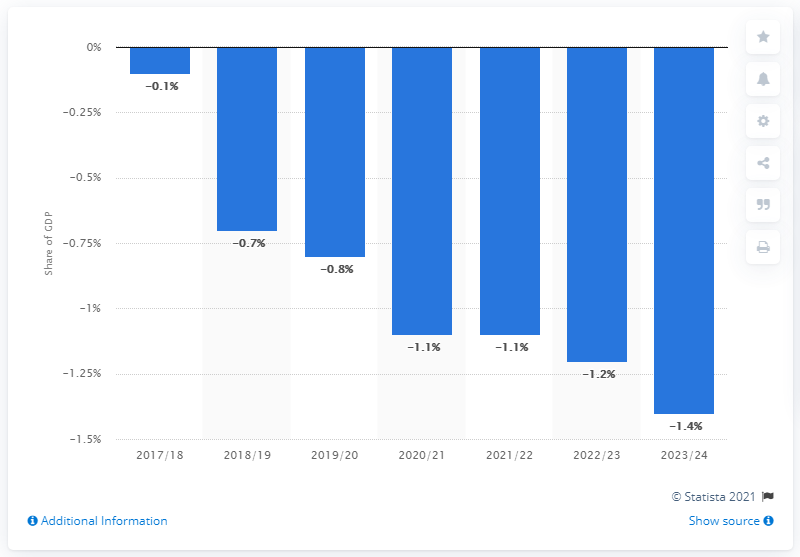Draw attention to some important aspects in this diagram. The current budget deficit in the United Kingdom was in 2017/2018. The current budget deficit in the United Kingdom is projected to end in the 2023/24 fiscal year. 